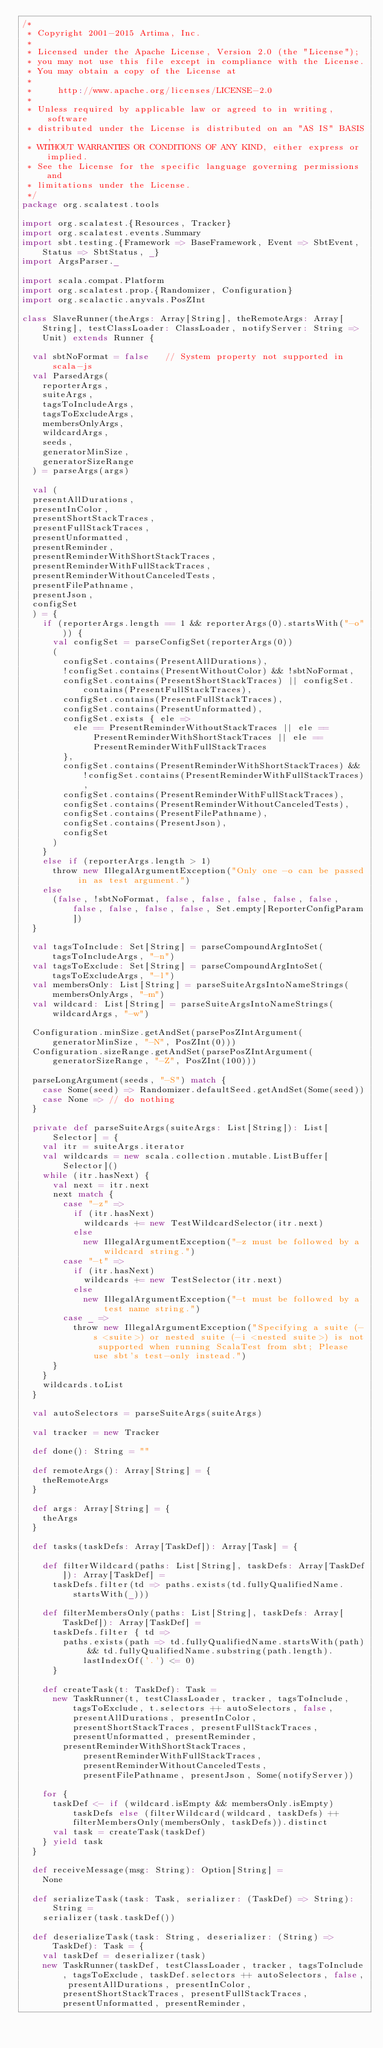Convert code to text. <code><loc_0><loc_0><loc_500><loc_500><_Scala_>/*
 * Copyright 2001-2015 Artima, Inc.
 *
 * Licensed under the Apache License, Version 2.0 (the "License");
 * you may not use this file except in compliance with the License.
 * You may obtain a copy of the License at
 *
 *     http://www.apache.org/licenses/LICENSE-2.0
 *
 * Unless required by applicable law or agreed to in writing, software
 * distributed under the License is distributed on an "AS IS" BASIS,
 * WITHOUT WARRANTIES OR CONDITIONS OF ANY KIND, either express or implied.
 * See the License for the specific language governing permissions and
 * limitations under the License.
 */
package org.scalatest.tools

import org.scalatest.{Resources, Tracker}
import org.scalatest.events.Summary
import sbt.testing.{Framework => BaseFramework, Event => SbtEvent, Status => SbtStatus, _}
import ArgsParser._

import scala.compat.Platform
import org.scalatest.prop.{Randomizer, Configuration}
import org.scalactic.anyvals.PosZInt

class SlaveRunner(theArgs: Array[String], theRemoteArgs: Array[String], testClassLoader: ClassLoader, notifyServer: String => Unit) extends Runner {

  val sbtNoFormat = false   // System property not supported in scala-js
  val ParsedArgs(
    reporterArgs,
    suiteArgs,
    tagsToIncludeArgs,
    tagsToExcludeArgs,
    membersOnlyArgs,
    wildcardArgs,
    seeds,
    generatorMinSize,
    generatorSizeRange
  ) = parseArgs(args)

  val (
  presentAllDurations,
  presentInColor,
  presentShortStackTraces,
  presentFullStackTraces,
  presentUnformatted,
  presentReminder,
  presentReminderWithShortStackTraces,
  presentReminderWithFullStackTraces,
  presentReminderWithoutCanceledTests,
  presentFilePathname,
  presentJson,
  configSet
  ) = {
    if (reporterArgs.length == 1 && reporterArgs(0).startsWith("-o")) {
      val configSet = parseConfigSet(reporterArgs(0))
      (
        configSet.contains(PresentAllDurations),
        !configSet.contains(PresentWithoutColor) && !sbtNoFormat,
        configSet.contains(PresentShortStackTraces) || configSet.contains(PresentFullStackTraces),
        configSet.contains(PresentFullStackTraces),
        configSet.contains(PresentUnformatted),
        configSet.exists { ele =>
          ele == PresentReminderWithoutStackTraces || ele == PresentReminderWithShortStackTraces || ele == PresentReminderWithFullStackTraces
        },
        configSet.contains(PresentReminderWithShortStackTraces) && !configSet.contains(PresentReminderWithFullStackTraces),
        configSet.contains(PresentReminderWithFullStackTraces),
        configSet.contains(PresentReminderWithoutCanceledTests),
        configSet.contains(PresentFilePathname),
        configSet.contains(PresentJson),
        configSet
      )
    }
    else if (reporterArgs.length > 1)
      throw new IllegalArgumentException("Only one -o can be passed in as test argument.")
    else
      (false, !sbtNoFormat, false, false, false, false, false, false, false, false, false, Set.empty[ReporterConfigParam])
  }

  val tagsToInclude: Set[String] = parseCompoundArgIntoSet(tagsToIncludeArgs, "-n")
  val tagsToExclude: Set[String] = parseCompoundArgIntoSet(tagsToExcludeArgs, "-l")
  val membersOnly: List[String] = parseSuiteArgsIntoNameStrings(membersOnlyArgs, "-m")
  val wildcard: List[String] = parseSuiteArgsIntoNameStrings(wildcardArgs, "-w")

  Configuration.minSize.getAndSet(parsePosZIntArgument(generatorMinSize, "-N", PosZInt(0)))
  Configuration.sizeRange.getAndSet(parsePosZIntArgument(generatorSizeRange, "-Z", PosZInt(100)))

  parseLongArgument(seeds, "-S") match {
    case Some(seed) => Randomizer.defaultSeed.getAndSet(Some(seed))
    case None => // do nothing
  }

  private def parseSuiteArgs(suiteArgs: List[String]): List[Selector] = {
    val itr = suiteArgs.iterator
    val wildcards = new scala.collection.mutable.ListBuffer[Selector]()
    while (itr.hasNext) {
      val next = itr.next
      next match {
        case "-z" =>
          if (itr.hasNext)
            wildcards += new TestWildcardSelector(itr.next)
          else
            new IllegalArgumentException("-z must be followed by a wildcard string.")
        case "-t" =>
          if (itr.hasNext)
            wildcards += new TestSelector(itr.next)
          else
            new IllegalArgumentException("-t must be followed by a test name string.")
        case _ =>
          throw new IllegalArgumentException("Specifying a suite (-s <suite>) or nested suite (-i <nested suite>) is not supported when running ScalaTest from sbt; Please use sbt's test-only instead.")
      }
    }
    wildcards.toList
  }

  val autoSelectors = parseSuiteArgs(suiteArgs)

  val tracker = new Tracker

  def done(): String = ""

  def remoteArgs(): Array[String] = {
    theRemoteArgs
  }

  def args: Array[String] = {
    theArgs
  }

  def tasks(taskDefs: Array[TaskDef]): Array[Task] = {

    def filterWildcard(paths: List[String], taskDefs: Array[TaskDef]): Array[TaskDef] =
      taskDefs.filter(td => paths.exists(td.fullyQualifiedName.startsWith(_)))

    def filterMembersOnly(paths: List[String], taskDefs: Array[TaskDef]): Array[TaskDef] =
      taskDefs.filter { td =>
        paths.exists(path => td.fullyQualifiedName.startsWith(path) && td.fullyQualifiedName.substring(path.length).lastIndexOf('.') <= 0)
      }

    def createTask(t: TaskDef): Task =
      new TaskRunner(t, testClassLoader, tracker, tagsToInclude, tagsToExclude, t.selectors ++ autoSelectors, false, presentAllDurations, presentInColor, presentShortStackTraces, presentFullStackTraces, presentUnformatted, presentReminder,
        presentReminderWithShortStackTraces, presentReminderWithFullStackTraces, presentReminderWithoutCanceledTests, presentFilePathname, presentJson, Some(notifyServer))

    for {
      taskDef <- if (wildcard.isEmpty && membersOnly.isEmpty) taskDefs else (filterWildcard(wildcard, taskDefs) ++ filterMembersOnly(membersOnly, taskDefs)).distinct
      val task = createTask(taskDef)
    } yield task
  }

  def receiveMessage(msg: String): Option[String] =
    None

  def serializeTask(task: Task, serializer: (TaskDef) => String): String =
    serializer(task.taskDef())

  def deserializeTask(task: String, deserializer: (String) => TaskDef): Task = {
    val taskDef = deserializer(task)
    new TaskRunner(taskDef, testClassLoader, tracker, tagsToInclude, tagsToExclude, taskDef.selectors ++ autoSelectors, false, presentAllDurations, presentInColor, presentShortStackTraces, presentFullStackTraces, presentUnformatted, presentReminder,</code> 